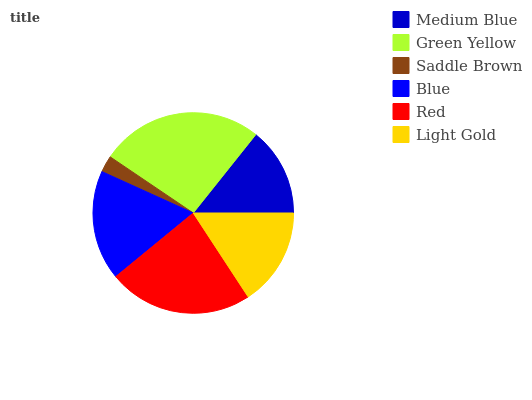Is Saddle Brown the minimum?
Answer yes or no. Yes. Is Green Yellow the maximum?
Answer yes or no. Yes. Is Green Yellow the minimum?
Answer yes or no. No. Is Saddle Brown the maximum?
Answer yes or no. No. Is Green Yellow greater than Saddle Brown?
Answer yes or no. Yes. Is Saddle Brown less than Green Yellow?
Answer yes or no. Yes. Is Saddle Brown greater than Green Yellow?
Answer yes or no. No. Is Green Yellow less than Saddle Brown?
Answer yes or no. No. Is Blue the high median?
Answer yes or no. Yes. Is Light Gold the low median?
Answer yes or no. Yes. Is Green Yellow the high median?
Answer yes or no. No. Is Medium Blue the low median?
Answer yes or no. No. 